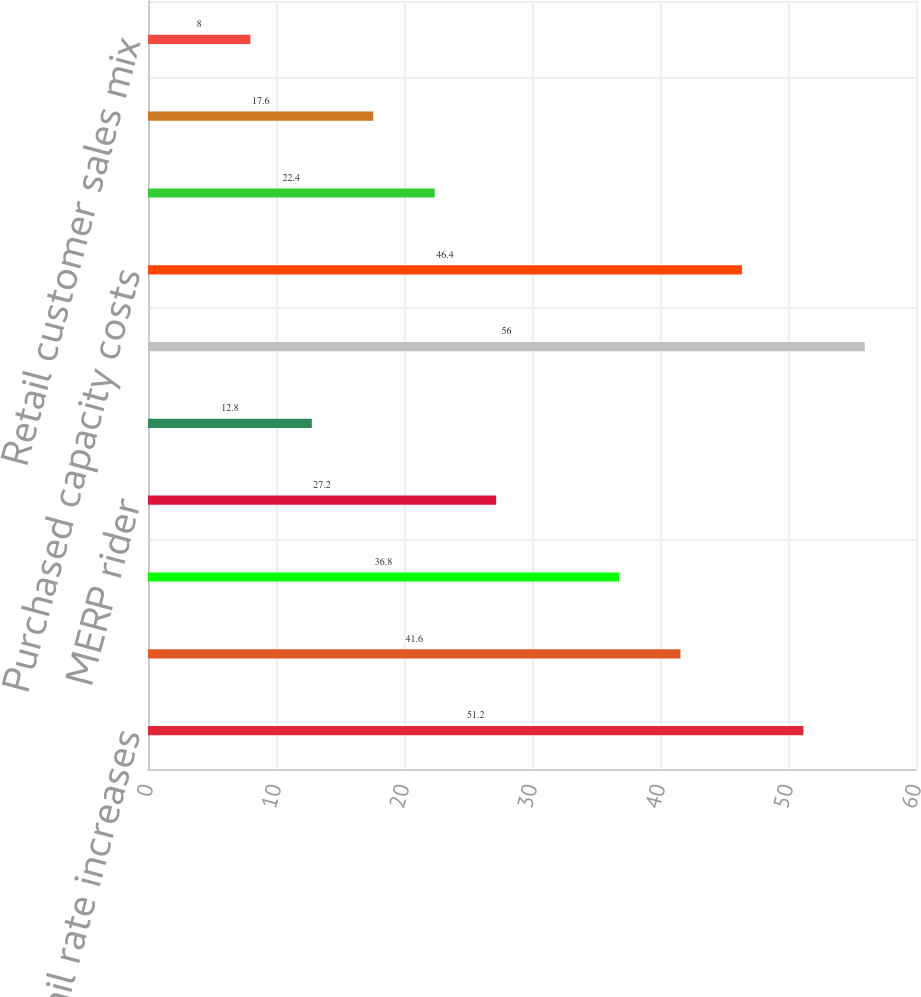Convert chart to OTSL. <chart><loc_0><loc_0><loc_500><loc_500><bar_chart><fcel>Retail rate increases<fcel>Retail sales growth (excluding<fcel>Conservation and non-fuel<fcel>MERP rider<fcel>Increased revenue due to leap<fcel>Estimated impact of weather<fcel>Purchased capacity costs<fcel>Revenue subject to refund due<fcel>Trading margin<fcel>Retail customer sales mix<nl><fcel>51.2<fcel>41.6<fcel>36.8<fcel>27.2<fcel>12.8<fcel>56<fcel>46.4<fcel>22.4<fcel>17.6<fcel>8<nl></chart> 